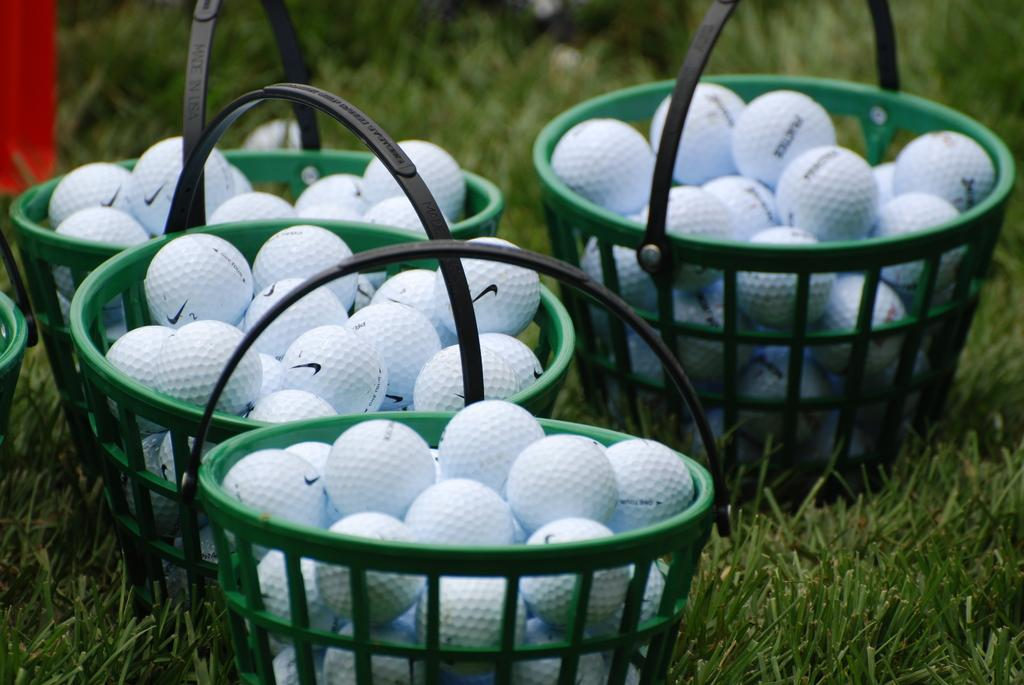What objects are present in the image that can hold items? There are baskets in the image that can hold items. What are the baskets holding? The baskets contain balls. Can you describe the colorful element in the top left corner of the image? There is a red color cloth in the top left corner of the image. What type of natural environment is visible in the background of the image? There is grass visible in the background of the image. What type of tax is being discussed in the image? There is no discussion of tax in the image; it features baskets containing balls and a red color cloth. How many bikes can be seen in the image? There are no bikes present in the image. 